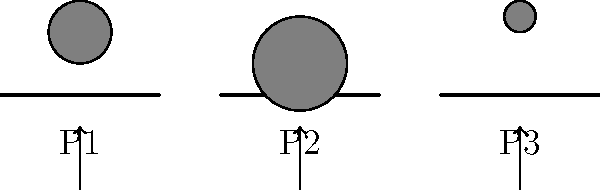In the illustration above, three processors (P1, P2, and P3) are represented by scales with different workloads. If the goal is to achieve optimal load balancing, which processor should receive the next incoming task to maintain equilibrium in the parallel computing system? To determine which processor should receive the next task for optimal load balancing, we need to analyze the current workload distribution:

1. Observe the weights on each scale:
   - P1 has a medium-sized weight
   - P2 has the largest weight
   - P3 has the smallest weight

2. In parallel computing, load balancing aims to distribute tasks evenly across all processors to maximize efficiency and minimize idle time.

3. The principle of load balancing suggests assigning new tasks to the processor with the least current workload.

4. Comparing the weights:
   - P3 has the lightest load
   - P1 has a moderate load
   - P2 has the heaviest load

5. To maintain equilibrium and achieve optimal load balancing, the next incoming task should be assigned to the processor with the lightest current load.

Therefore, the processor that should receive the next incoming task is P3, as it currently has the smallest workload and can handle additional tasks without becoming overloaded.
Answer: P3 